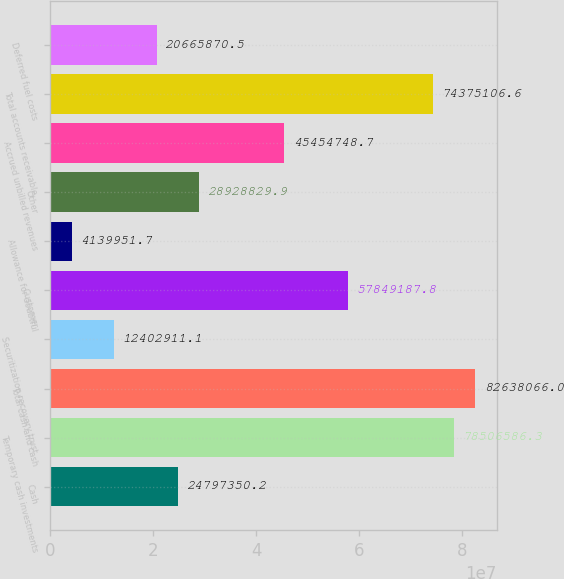<chart> <loc_0><loc_0><loc_500><loc_500><bar_chart><fcel>Cash<fcel>Temporary cash investments<fcel>Total cash and cash<fcel>Securitization recovery trust<fcel>Customer<fcel>Allowance for doubtful<fcel>Other<fcel>Accrued unbilled revenues<fcel>Total accounts receivable<fcel>Deferred fuel costs<nl><fcel>2.47974e+07<fcel>7.85066e+07<fcel>8.26381e+07<fcel>1.24029e+07<fcel>5.78492e+07<fcel>4.13995e+06<fcel>2.89288e+07<fcel>4.54547e+07<fcel>7.43751e+07<fcel>2.06659e+07<nl></chart> 